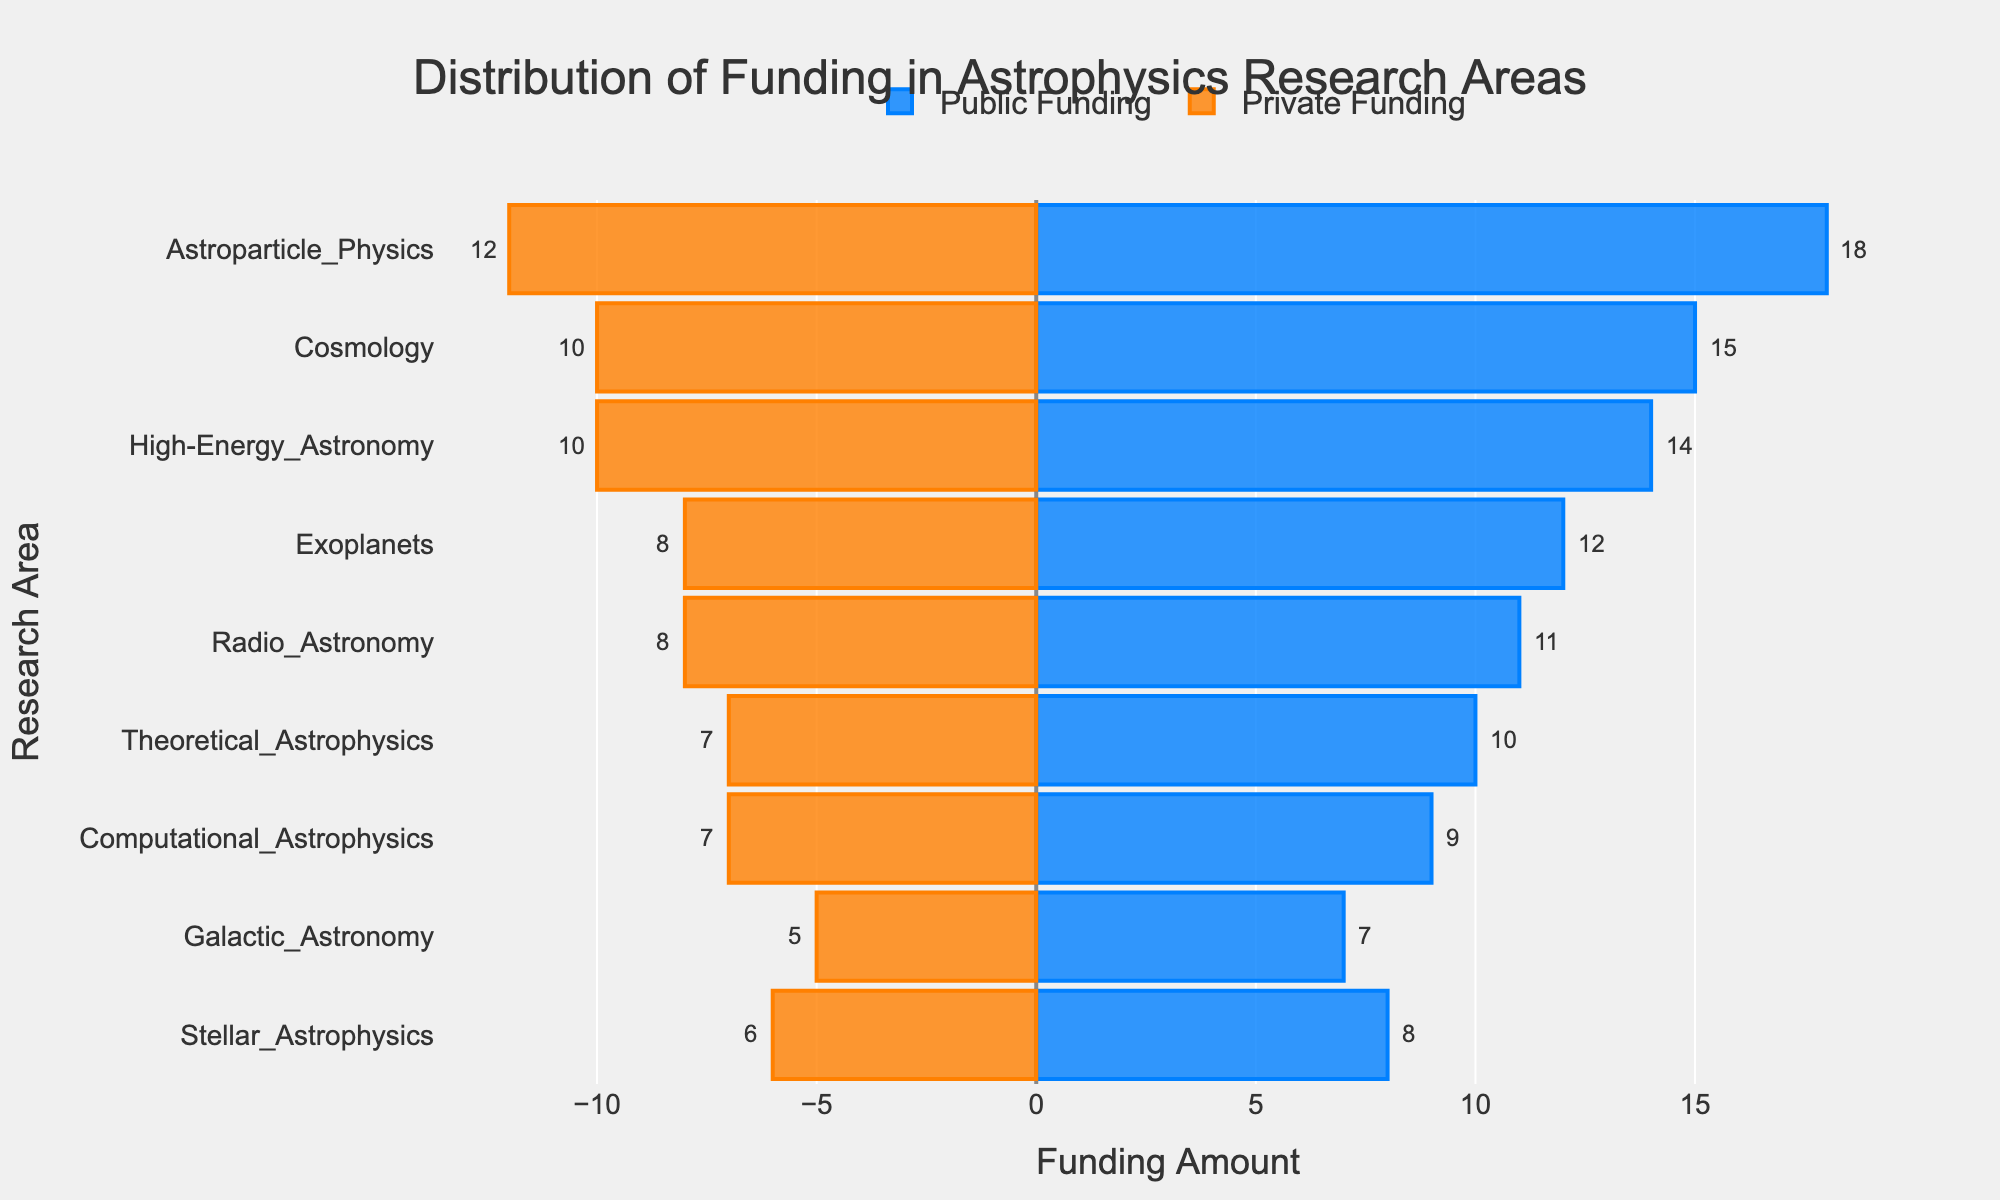How much more public funding does Astroparticle Physics receive compared to private funding? To find out how much more public funding Astroparticle Physics receives compared to private funding, look at the difference between the Public Funding and Private Funding for Astroparticle Physics. Public Funding for Astroparticle Physics is 18, and Private Funding is 12, so the difference is 18 - 12.
Answer: 6 Which research area receives the least amount of public funding and how much is it? To determine the research area that receives the least amount of public funding, check the leftward horizontal bars and find the smallest value among them. Galactic Astronomy receives the least amount of public funding, which is 7.
Answer: Galactic Astronomy, 7 Which research area has the smallest gap between public and private funding? The research area with the smallest gap between public and private funding can be found by identifying the smallest difference in the lengths of the corresponding bars. Stellar Astrophysics has a difference of 8 (Public) - 6 (Private) = 2, which is the smallest gap.
Answer: Stellar Astrophysics Compare the public and private funding for High-Energy Astronomy. Which one is higher and by what amount? To compare the public and private funding for High-Energy Astronomy, look at the lengths of the respective bars. Public Funding for High-Energy Astronomy is 14, and Private Funding is 10. The difference is 14 - 10. Public Funding is higher by 4.
Answer: Public, 4 Which research area has the second highest amount of private funding? To find the research area with the second highest amount of private funding, identify the lengths of the rightward bars and sort them in descending order. The second longest bar corresponds to Exoplanets with a private funding of 8.
Answer: Exoplanets What is the combined funding (public + private) for Cosmology? To calculate the total combined funding for Cosmology, add its Public Funding and Private Funding. Public Funding is 15 and Private Funding is 10, so you sum them up: 15 + 10.
Answer: 25 Which research area receives equal public and private funding, if any? To determine if any research area receives equal amounts of public and private funding, check if the lengths of both bars (public and private) are the same for any research area. No research area has equal public and private funding.
Answer: None Which research area is closest to having a balanced distribution between public and private funding? The research area closest to having balanced funding can be identified by finding the smallest relative difference between its Public and Private Funding. Stellar Astrophysics has public funding of 8 and private funding of 6, resulting in a relative difference of 2, the smallest among all research areas.
Answer: Stellar Astrophysics 